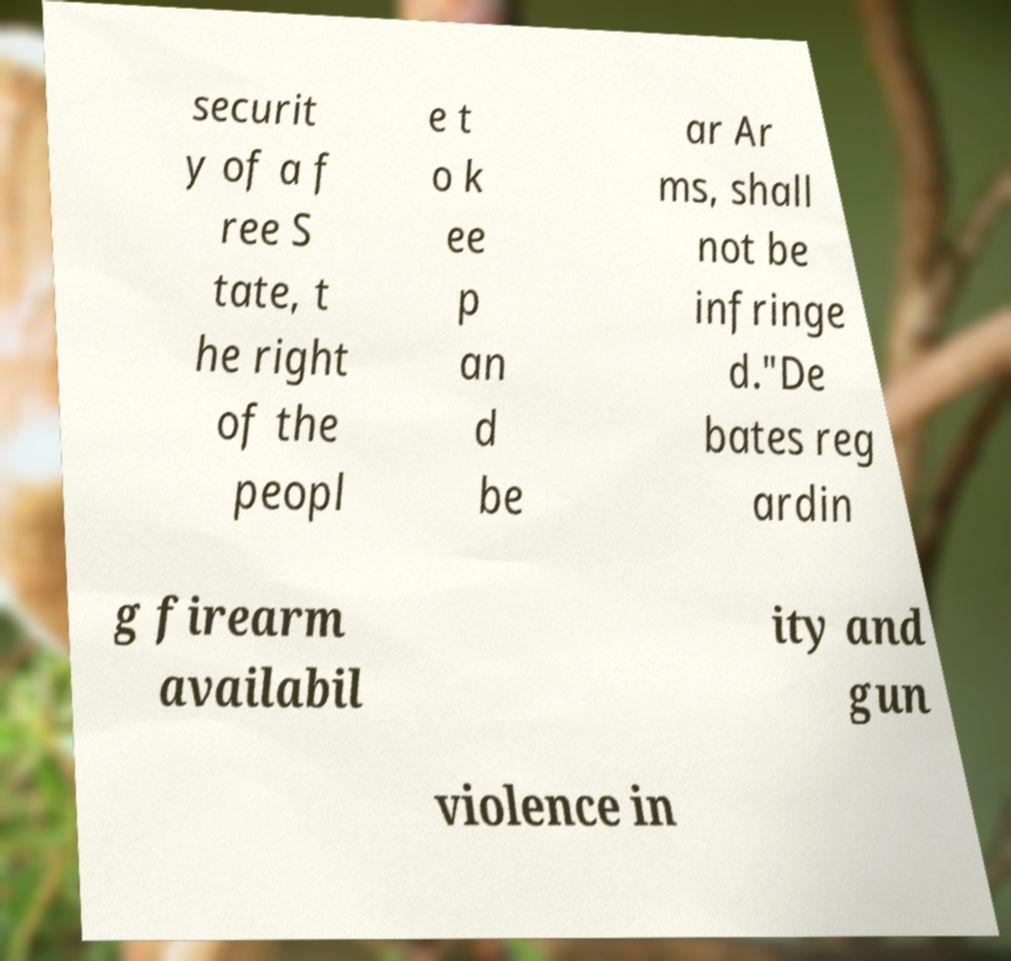For documentation purposes, I need the text within this image transcribed. Could you provide that? securit y of a f ree S tate, t he right of the peopl e t o k ee p an d be ar Ar ms, shall not be infringe d."De bates reg ardin g firearm availabil ity and gun violence in 